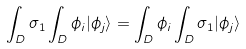<formula> <loc_0><loc_0><loc_500><loc_500>\int _ { D } \sigma _ { 1 } \int _ { D } \phi _ { i } | \phi _ { j } \rangle = \int _ { D } \phi _ { i } \int _ { D } \sigma _ { 1 } | \phi _ { j } \rangle \,</formula> 